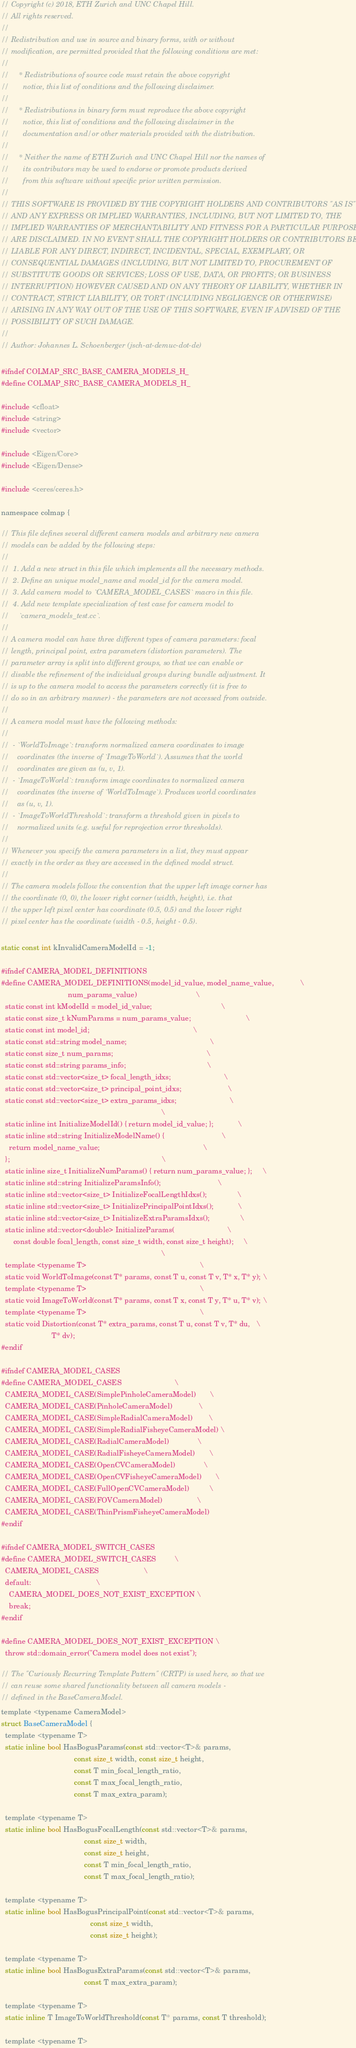<code> <loc_0><loc_0><loc_500><loc_500><_C_>// Copyright (c) 2018, ETH Zurich and UNC Chapel Hill.
// All rights reserved.
//
// Redistribution and use in source and binary forms, with or without
// modification, are permitted provided that the following conditions are met:
//
//     * Redistributions of source code must retain the above copyright
//       notice, this list of conditions and the following disclaimer.
//
//     * Redistributions in binary form must reproduce the above copyright
//       notice, this list of conditions and the following disclaimer in the
//       documentation and/or other materials provided with the distribution.
//
//     * Neither the name of ETH Zurich and UNC Chapel Hill nor the names of
//       its contributors may be used to endorse or promote products derived
//       from this software without specific prior written permission.
//
// THIS SOFTWARE IS PROVIDED BY THE COPYRIGHT HOLDERS AND CONTRIBUTORS "AS IS"
// AND ANY EXPRESS OR IMPLIED WARRANTIES, INCLUDING, BUT NOT LIMITED TO, THE
// IMPLIED WARRANTIES OF MERCHANTABILITY AND FITNESS FOR A PARTICULAR PURPOSE
// ARE DISCLAIMED. IN NO EVENT SHALL THE COPYRIGHT HOLDERS OR CONTRIBUTORS BE
// LIABLE FOR ANY DIRECT, INDIRECT, INCIDENTAL, SPECIAL, EXEMPLARY, OR
// CONSEQUENTIAL DAMAGES (INCLUDING, BUT NOT LIMITED TO, PROCUREMENT OF
// SUBSTITUTE GOODS OR SERVICES; LOSS OF USE, DATA, OR PROFITS; OR BUSINESS
// INTERRUPTION) HOWEVER CAUSED AND ON ANY THEORY OF LIABILITY, WHETHER IN
// CONTRACT, STRICT LIABILITY, OR TORT (INCLUDING NEGLIGENCE OR OTHERWISE)
// ARISING IN ANY WAY OUT OF THE USE OF THIS SOFTWARE, EVEN IF ADVISED OF THE
// POSSIBILITY OF SUCH DAMAGE.
//
// Author: Johannes L. Schoenberger (jsch-at-demuc-dot-de)

#ifndef COLMAP_SRC_BASE_CAMERA_MODELS_H_
#define COLMAP_SRC_BASE_CAMERA_MODELS_H_

#include <cfloat>
#include <string>
#include <vector>

#include <Eigen/Core>
#include <Eigen/Dense>

#include <ceres/ceres.h>

namespace colmap {

// This file defines several different camera models and arbitrary new camera
// models can be added by the following steps:
//
//  1. Add a new struct in this file which implements all the necessary methods.
//  2. Define an unique model_name and model_id for the camera model.
//  3. Add camera model to `CAMERA_MODEL_CASES` macro in this file.
//  4. Add new template specialization of test case for camera model to
//     `camera_models_test.cc`.
//
// A camera model can have three different types of camera parameters: focal
// length, principal point, extra parameters (distortion parameters). The
// parameter array is split into different groups, so that we can enable or
// disable the refinement of the individual groups during bundle adjustment. It
// is up to the camera model to access the parameters correctly (it is free to
// do so in an arbitrary manner) - the parameters are not accessed from outside.
//
// A camera model must have the following methods:
//
//  - `WorldToImage`: transform normalized camera coordinates to image
//    coordinates (the inverse of `ImageToWorld`). Assumes that the world
//    coordinates are given as (u, v, 1).
//  - `ImageToWorld`: transform image coordinates to normalized camera
//    coordinates (the inverse of `WorldToImage`). Produces world coordinates
//    as (u, v, 1).
//  - `ImageToWorldThreshold`: transform a threshold given in pixels to
//    normalized units (e.g. useful for reprojection error thresholds).
//
// Whenever you specify the camera parameters in a list, they must appear
// exactly in the order as they are accessed in the defined model struct.
//
// The camera models follow the convention that the upper left image corner has
// the coordinate (0, 0), the lower right corner (width, height), i.e. that
// the upper left pixel center has coordinate (0.5, 0.5) and the lower right
// pixel center has the coordinate (width - 0.5, height - 0.5).

static const int kInvalidCameraModelId = -1;

#ifndef CAMERA_MODEL_DEFINITIONS
#define CAMERA_MODEL_DEFINITIONS(model_id_value, model_name_value,             \
                                 num_params_value)                             \
  static const int kModelId = model_id_value;                                  \
  static const size_t kNumParams = num_params_value;                           \
  static const int model_id;                                                   \
  static const std::string model_name;                                         \
  static const size_t num_params;                                              \
  static const std::string params_info;                                        \
  static const std::vector<size_t> focal_length_idxs;                          \
  static const std::vector<size_t> principal_point_idxs;                       \
  static const std::vector<size_t> extra_params_idxs;                          \
                                                                               \
  static inline int InitializeModelId() { return model_id_value; };            \
  static inline std::string InitializeModelName() {                            \
    return model_name_value;                                                   \
  };                                                                           \
  static inline size_t InitializeNumParams() { return num_params_value; };     \
  static inline std::string InitializeParamsInfo();                            \
  static inline std::vector<size_t> InitializeFocalLengthIdxs();               \
  static inline std::vector<size_t> InitializePrincipalPointIdxs();            \
  static inline std::vector<size_t> InitializeExtraParamsIdxs();               \
  static inline std::vector<double> InitializeParams(                          \
      const double focal_length, const size_t width, const size_t height);     \
                                                                               \
  template <typename T>                                                        \
  static void WorldToImage(const T* params, const T u, const T v, T* x, T* y); \
  template <typename T>                                                        \
  static void ImageToWorld(const T* params, const T x, const T y, T* u, T* v); \
  template <typename T>                                                        \
  static void Distortion(const T* extra_params, const T u, const T v, T* du,   \
                         T* dv);
#endif

#ifndef CAMERA_MODEL_CASES
#define CAMERA_MODEL_CASES                          \
  CAMERA_MODEL_CASE(SimplePinholeCameraModel)       \
  CAMERA_MODEL_CASE(PinholeCameraModel)             \
  CAMERA_MODEL_CASE(SimpleRadialCameraModel)        \
  CAMERA_MODEL_CASE(SimpleRadialFisheyeCameraModel) \
  CAMERA_MODEL_CASE(RadialCameraModel)              \
  CAMERA_MODEL_CASE(RadialFisheyeCameraModel)       \
  CAMERA_MODEL_CASE(OpenCVCameraModel)              \
  CAMERA_MODEL_CASE(OpenCVFisheyeCameraModel)       \
  CAMERA_MODEL_CASE(FullOpenCVCameraModel)          \
  CAMERA_MODEL_CASE(FOVCameraModel)                 \
  CAMERA_MODEL_CASE(ThinPrismFisheyeCameraModel)
#endif

#ifndef CAMERA_MODEL_SWITCH_CASES
#define CAMERA_MODEL_SWITCH_CASES         \
  CAMERA_MODEL_CASES                      \
  default:                                \
    CAMERA_MODEL_DOES_NOT_EXIST_EXCEPTION \
    break;
#endif

#define CAMERA_MODEL_DOES_NOT_EXIST_EXCEPTION \
  throw std::domain_error("Camera model does not exist");

// The "Curiously Recurring Template Pattern" (CRTP) is used here, so that we
// can reuse some shared functionality between all camera models -
// defined in the BaseCameraModel.
template <typename CameraModel>
struct BaseCameraModel {
  template <typename T>
  static inline bool HasBogusParams(const std::vector<T>& params,
                                    const size_t width, const size_t height,
                                    const T min_focal_length_ratio,
                                    const T max_focal_length_ratio,
                                    const T max_extra_param);

  template <typename T>
  static inline bool HasBogusFocalLength(const std::vector<T>& params,
                                         const size_t width,
                                         const size_t height,
                                         const T min_focal_length_ratio,
                                         const T max_focal_length_ratio);

  template <typename T>
  static inline bool HasBogusPrincipalPoint(const std::vector<T>& params,
                                            const size_t width,
                                            const size_t height);

  template <typename T>
  static inline bool HasBogusExtraParams(const std::vector<T>& params,
                                         const T max_extra_param);

  template <typename T>
  static inline T ImageToWorldThreshold(const T* params, const T threshold);

  template <typename T></code> 